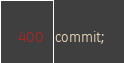Convert code to text. <code><loc_0><loc_0><loc_500><loc_500><_SQL_>commit;</code> 